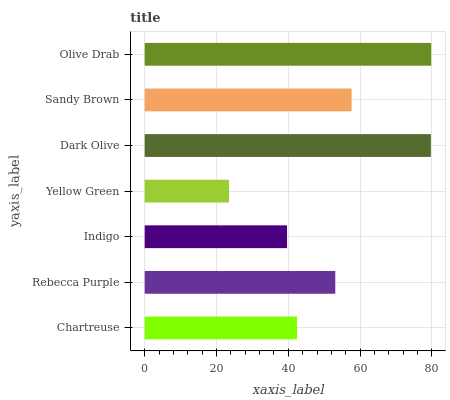Is Yellow Green the minimum?
Answer yes or no. Yes. Is Olive Drab the maximum?
Answer yes or no. Yes. Is Rebecca Purple the minimum?
Answer yes or no. No. Is Rebecca Purple the maximum?
Answer yes or no. No. Is Rebecca Purple greater than Chartreuse?
Answer yes or no. Yes. Is Chartreuse less than Rebecca Purple?
Answer yes or no. Yes. Is Chartreuse greater than Rebecca Purple?
Answer yes or no. No. Is Rebecca Purple less than Chartreuse?
Answer yes or no. No. Is Rebecca Purple the high median?
Answer yes or no. Yes. Is Rebecca Purple the low median?
Answer yes or no. Yes. Is Sandy Brown the high median?
Answer yes or no. No. Is Olive Drab the low median?
Answer yes or no. No. 